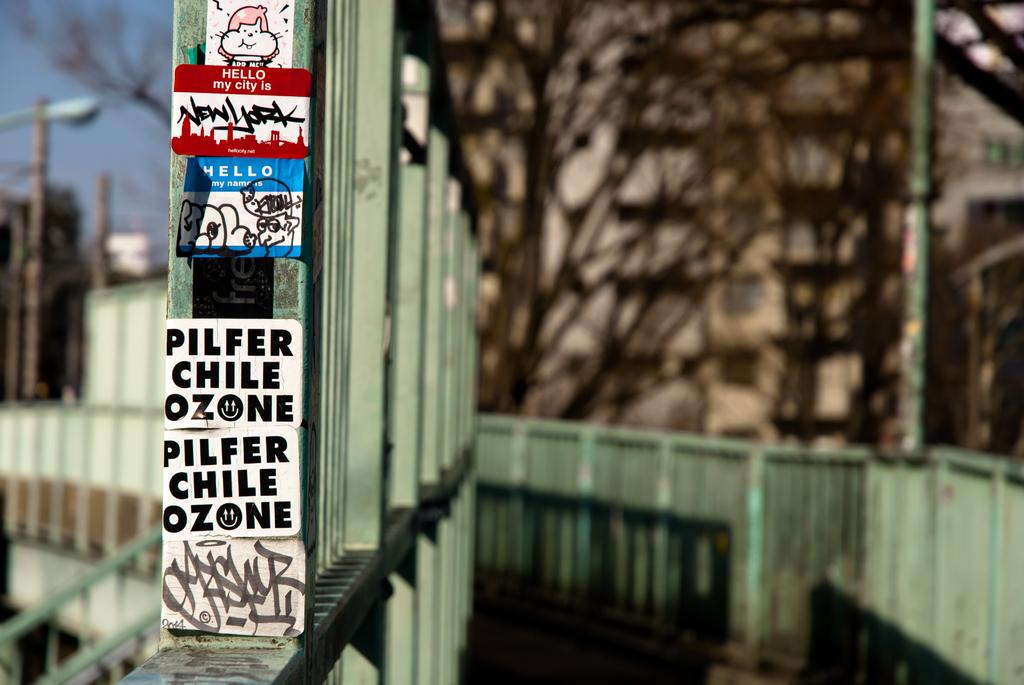What is located in the center of the image? In the center of the image, there are poles, posters, a wall, and a fence, along with other objects. Can you describe the background of the image? The sky and trees are visible in the background of the image. What type of objects can be seen in the center of the image? Besides the poles, posters, wall, and fence, there are other objects present in the center of the image. Can you tell me what time the watch is showing in the image? There is no watch present in the image. How many goldfish are swimming in the background of the image? There are no goldfish present in the image. 